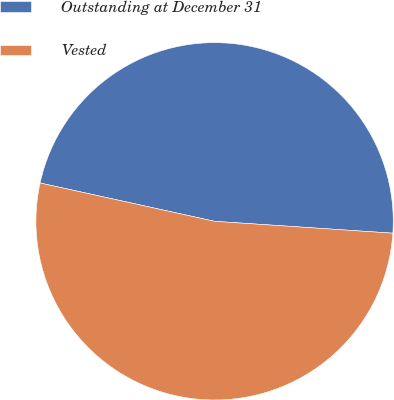<chart> <loc_0><loc_0><loc_500><loc_500><pie_chart><fcel>Outstanding at December 31<fcel>Vested<nl><fcel>47.62%<fcel>52.38%<nl></chart> 